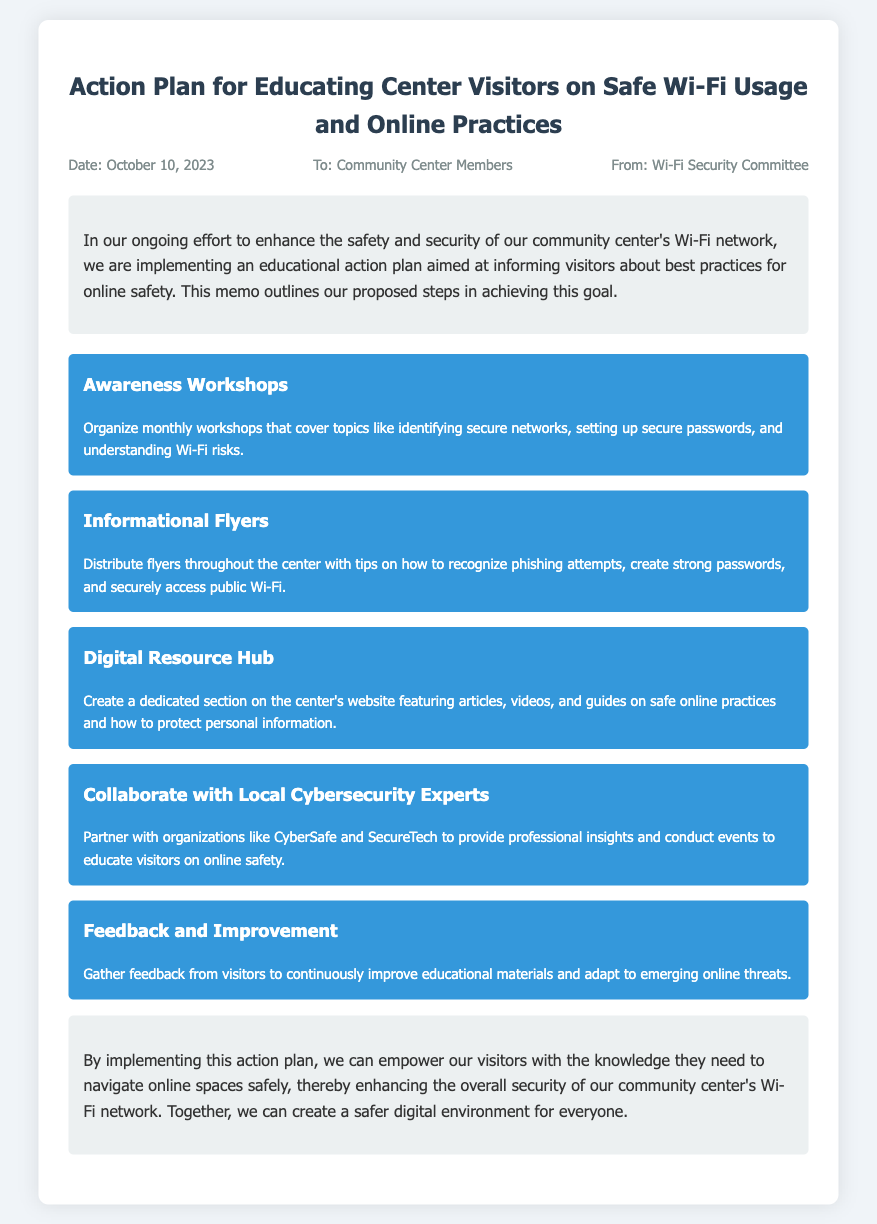What is the title of the document? The title of the document is specified in the heading of the memo.
Answer: Action Plan for Educating Center Visitors on Safe Wi-Fi Usage and Online Practices When was the memo written? The date of the memo is listed in the meta section at the top of the document.
Answer: October 10, 2023 Who is the memo addressed to? The recipient of the memo is mentioned in the meta section.
Answer: Community Center Members What is one topic covered in the Awareness Workshops? The specific topics are listed under the action items.
Answer: Identifying secure networks What is a method proposed to provide information to visitors? The document lists various action items for educating visitors.
Answer: Informational Flyers Which organizations are mentioned for collaboration? The document refers to partnerships with specific organizations for support.
Answer: CyberSafe and SecureTech What section is dedicated to online safety resources? The document outlines a specific feature of the center's website.
Answer: Digital Resource Hub What is the goal of the feedback and improvement action? The purpose of this action item is detailed in the corresponding section.
Answer: Continuously improve educational materials What color scheme is primarily used in the memo design? The colors used for the background and text give a clue about the memo's visual appeal.
Answer: Blue and white 